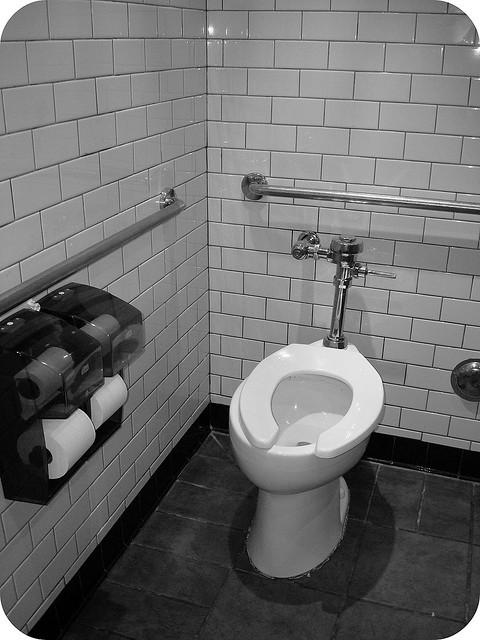What color is this toilet?
Write a very short answer. White. Is this a public toilet?
Short answer required. Yes. Is this life size?
Be succinct. Yes. What is the toilet made of?
Concise answer only. Porcelain. How many rolls of toilet paper are there?
Short answer required. 4. What color are the bars?
Short answer required. Silver. 